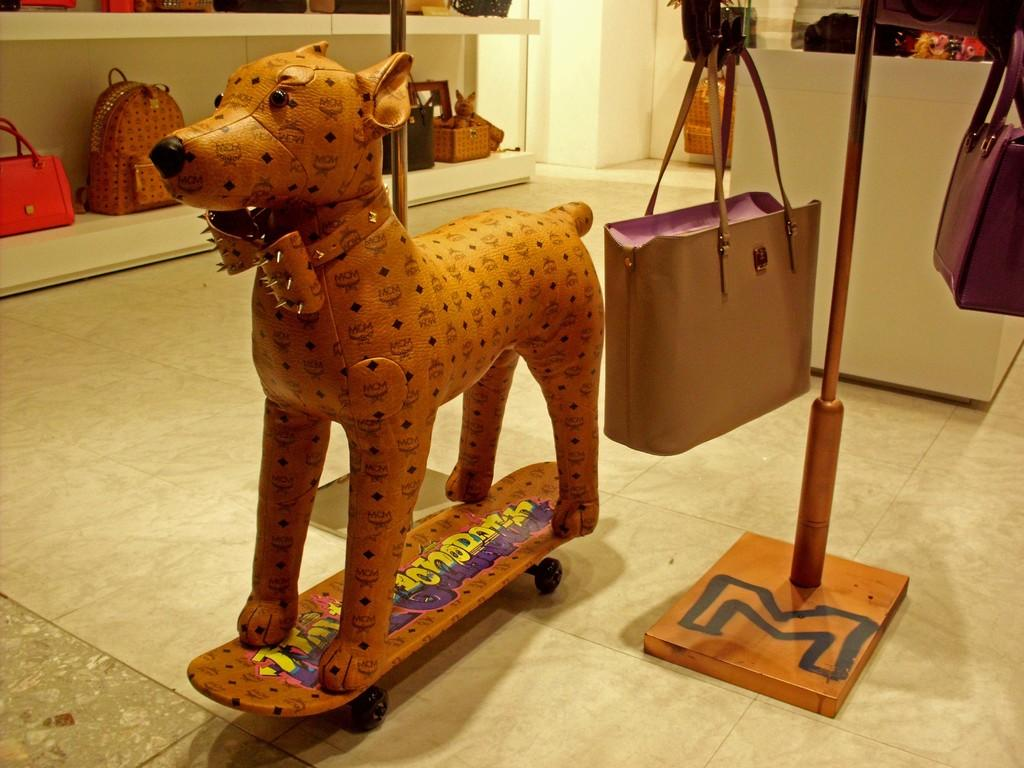What is the dog in the image playing with? The dog is playing with a ball in the image. What is the color of the dog? The dog is brown in color. How many gates are present in the image? There are no gates present in the image; it features a dog playing with a ball. What type of coach can be seen instructing the dog in the image? There is no coach present in the image; it only shows a dog playing with a ball. 